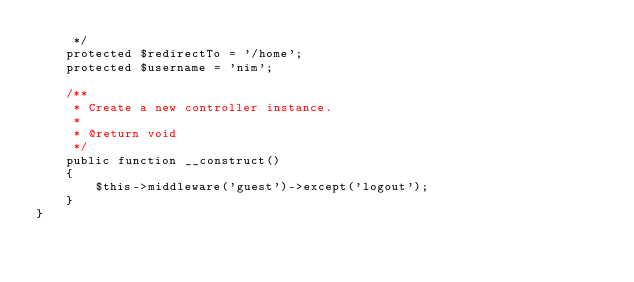<code> <loc_0><loc_0><loc_500><loc_500><_PHP_>     */
    protected $redirectTo = '/home';
    protected $username = 'nim';

    /**
     * Create a new controller instance.
     *
     * @return void
     */
    public function __construct()
    {
        $this->middleware('guest')->except('logout');
    }
}
</code> 